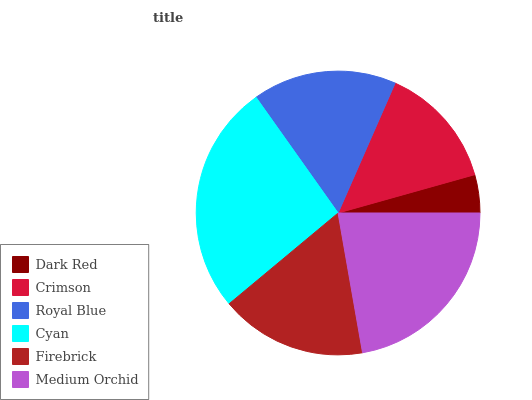Is Dark Red the minimum?
Answer yes or no. Yes. Is Cyan the maximum?
Answer yes or no. Yes. Is Crimson the minimum?
Answer yes or no. No. Is Crimson the maximum?
Answer yes or no. No. Is Crimson greater than Dark Red?
Answer yes or no. Yes. Is Dark Red less than Crimson?
Answer yes or no. Yes. Is Dark Red greater than Crimson?
Answer yes or no. No. Is Crimson less than Dark Red?
Answer yes or no. No. Is Firebrick the high median?
Answer yes or no. Yes. Is Royal Blue the low median?
Answer yes or no. Yes. Is Royal Blue the high median?
Answer yes or no. No. Is Firebrick the low median?
Answer yes or no. No. 